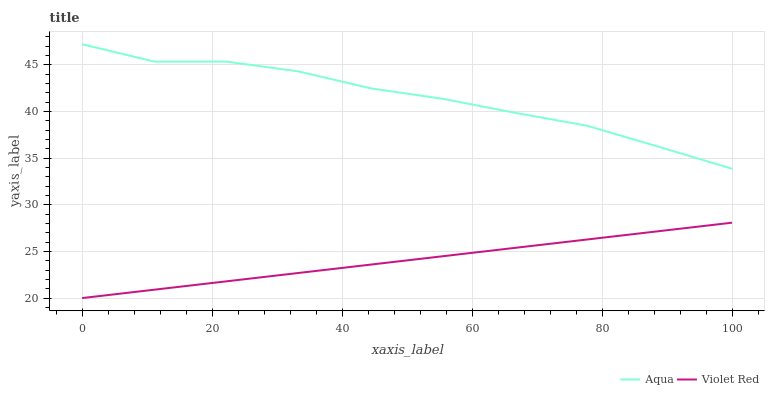Does Violet Red have the minimum area under the curve?
Answer yes or no. Yes. Does Aqua have the maximum area under the curve?
Answer yes or no. Yes. Does Aqua have the minimum area under the curve?
Answer yes or no. No. Is Violet Red the smoothest?
Answer yes or no. Yes. Is Aqua the roughest?
Answer yes or no. Yes. Is Aqua the smoothest?
Answer yes or no. No. Does Violet Red have the lowest value?
Answer yes or no. Yes. Does Aqua have the lowest value?
Answer yes or no. No. Does Aqua have the highest value?
Answer yes or no. Yes. Is Violet Red less than Aqua?
Answer yes or no. Yes. Is Aqua greater than Violet Red?
Answer yes or no. Yes. Does Violet Red intersect Aqua?
Answer yes or no. No. 